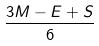Convert formula to latex. <formula><loc_0><loc_0><loc_500><loc_500>\frac { 3 M - E + S } { 6 }</formula> 